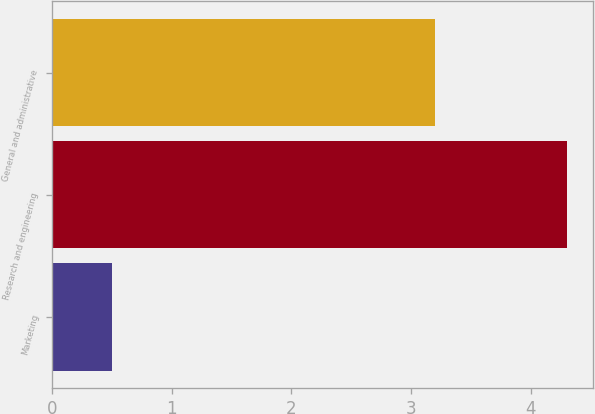Convert chart to OTSL. <chart><loc_0><loc_0><loc_500><loc_500><bar_chart><fcel>Marketing<fcel>Research and engineering<fcel>General and administrative<nl><fcel>0.5<fcel>4.3<fcel>3.2<nl></chart> 